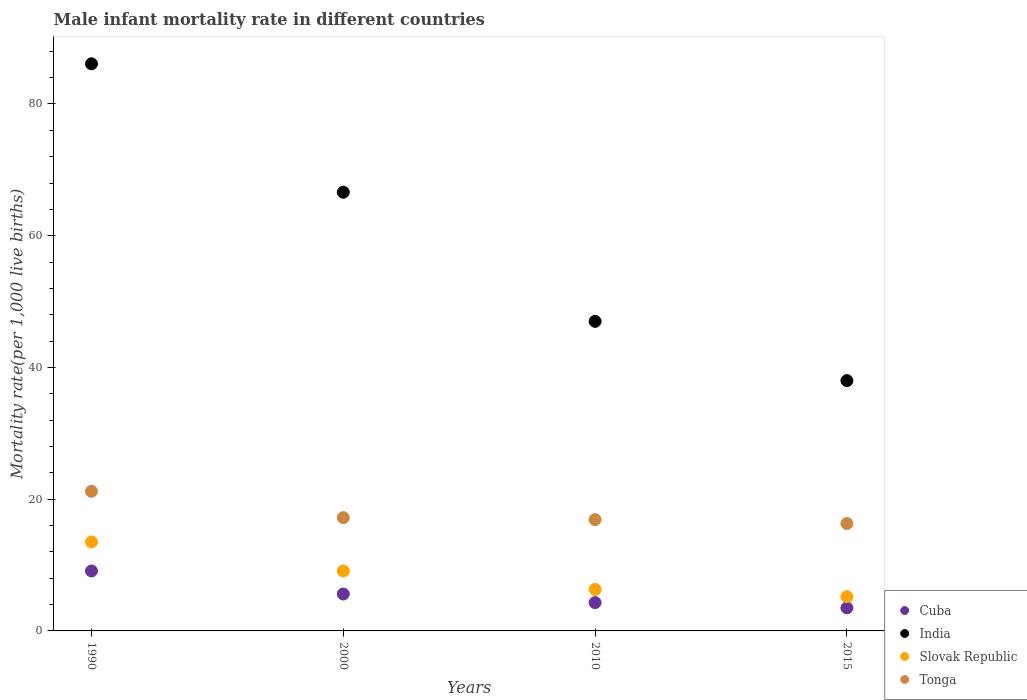What is the male infant mortality rate in India in 2000?
Your answer should be very brief. 66.6. In which year was the male infant mortality rate in Tonga minimum?
Offer a very short reply. 2015. What is the total male infant mortality rate in Tonga in the graph?
Provide a short and direct response. 71.6. What is the difference between the male infant mortality rate in Tonga in 2000 and that in 2015?
Ensure brevity in your answer.  0.9. What is the difference between the male infant mortality rate in Cuba in 1990 and the male infant mortality rate in Slovak Republic in 2000?
Offer a terse response. 0. In the year 2010, what is the difference between the male infant mortality rate in India and male infant mortality rate in Slovak Republic?
Your answer should be very brief. 40.7. What is the ratio of the male infant mortality rate in Cuba in 2010 to that in 2015?
Make the answer very short. 1.23. Is the male infant mortality rate in Cuba in 2010 less than that in 2015?
Keep it short and to the point. No. What is the difference between the highest and the second highest male infant mortality rate in Slovak Republic?
Give a very brief answer. 4.4. What is the difference between the highest and the lowest male infant mortality rate in Tonga?
Give a very brief answer. 4.9. In how many years, is the male infant mortality rate in Cuba greater than the average male infant mortality rate in Cuba taken over all years?
Make the answer very short. 1. Is the male infant mortality rate in Cuba strictly greater than the male infant mortality rate in India over the years?
Offer a terse response. No. How many years are there in the graph?
Give a very brief answer. 4. What is the difference between two consecutive major ticks on the Y-axis?
Your response must be concise. 20. Does the graph contain any zero values?
Provide a short and direct response. No. Does the graph contain grids?
Keep it short and to the point. No. How many legend labels are there?
Your answer should be compact. 4. What is the title of the graph?
Give a very brief answer. Male infant mortality rate in different countries. What is the label or title of the X-axis?
Your answer should be very brief. Years. What is the label or title of the Y-axis?
Provide a short and direct response. Mortality rate(per 1,0 live births). What is the Mortality rate(per 1,000 live births) in Cuba in 1990?
Offer a terse response. 9.1. What is the Mortality rate(per 1,000 live births) in India in 1990?
Ensure brevity in your answer.  86.1. What is the Mortality rate(per 1,000 live births) in Tonga in 1990?
Offer a terse response. 21.2. What is the Mortality rate(per 1,000 live births) in India in 2000?
Your answer should be very brief. 66.6. What is the Mortality rate(per 1,000 live births) of Tonga in 2000?
Provide a succinct answer. 17.2. What is the Mortality rate(per 1,000 live births) in India in 2010?
Provide a short and direct response. 47. What is the Mortality rate(per 1,000 live births) of India in 2015?
Offer a very short reply. 38. What is the Mortality rate(per 1,000 live births) in Slovak Republic in 2015?
Give a very brief answer. 5.2. What is the Mortality rate(per 1,000 live births) of Tonga in 2015?
Provide a short and direct response. 16.3. Across all years, what is the maximum Mortality rate(per 1,000 live births) in Cuba?
Give a very brief answer. 9.1. Across all years, what is the maximum Mortality rate(per 1,000 live births) in India?
Provide a short and direct response. 86.1. Across all years, what is the maximum Mortality rate(per 1,000 live births) in Tonga?
Give a very brief answer. 21.2. Across all years, what is the minimum Mortality rate(per 1,000 live births) in Cuba?
Keep it short and to the point. 3.5. Across all years, what is the minimum Mortality rate(per 1,000 live births) in Slovak Republic?
Your answer should be compact. 5.2. Across all years, what is the minimum Mortality rate(per 1,000 live births) of Tonga?
Make the answer very short. 16.3. What is the total Mortality rate(per 1,000 live births) in India in the graph?
Offer a terse response. 237.7. What is the total Mortality rate(per 1,000 live births) of Slovak Republic in the graph?
Keep it short and to the point. 34.1. What is the total Mortality rate(per 1,000 live births) of Tonga in the graph?
Ensure brevity in your answer.  71.6. What is the difference between the Mortality rate(per 1,000 live births) of Slovak Republic in 1990 and that in 2000?
Make the answer very short. 4.4. What is the difference between the Mortality rate(per 1,000 live births) in Tonga in 1990 and that in 2000?
Ensure brevity in your answer.  4. What is the difference between the Mortality rate(per 1,000 live births) in India in 1990 and that in 2010?
Keep it short and to the point. 39.1. What is the difference between the Mortality rate(per 1,000 live births) in India in 1990 and that in 2015?
Provide a short and direct response. 48.1. What is the difference between the Mortality rate(per 1,000 live births) of Slovak Republic in 1990 and that in 2015?
Make the answer very short. 8.3. What is the difference between the Mortality rate(per 1,000 live births) in Tonga in 1990 and that in 2015?
Offer a very short reply. 4.9. What is the difference between the Mortality rate(per 1,000 live births) of India in 2000 and that in 2010?
Give a very brief answer. 19.6. What is the difference between the Mortality rate(per 1,000 live births) in Slovak Republic in 2000 and that in 2010?
Provide a succinct answer. 2.8. What is the difference between the Mortality rate(per 1,000 live births) of Tonga in 2000 and that in 2010?
Keep it short and to the point. 0.3. What is the difference between the Mortality rate(per 1,000 live births) in Cuba in 2000 and that in 2015?
Provide a short and direct response. 2.1. What is the difference between the Mortality rate(per 1,000 live births) of India in 2000 and that in 2015?
Provide a succinct answer. 28.6. What is the difference between the Mortality rate(per 1,000 live births) in Tonga in 2000 and that in 2015?
Keep it short and to the point. 0.9. What is the difference between the Mortality rate(per 1,000 live births) in India in 2010 and that in 2015?
Make the answer very short. 9. What is the difference between the Mortality rate(per 1,000 live births) in Cuba in 1990 and the Mortality rate(per 1,000 live births) in India in 2000?
Your answer should be compact. -57.5. What is the difference between the Mortality rate(per 1,000 live births) of Cuba in 1990 and the Mortality rate(per 1,000 live births) of Slovak Republic in 2000?
Provide a succinct answer. 0. What is the difference between the Mortality rate(per 1,000 live births) of Cuba in 1990 and the Mortality rate(per 1,000 live births) of Tonga in 2000?
Your answer should be compact. -8.1. What is the difference between the Mortality rate(per 1,000 live births) in India in 1990 and the Mortality rate(per 1,000 live births) in Slovak Republic in 2000?
Provide a short and direct response. 77. What is the difference between the Mortality rate(per 1,000 live births) of India in 1990 and the Mortality rate(per 1,000 live births) of Tonga in 2000?
Offer a terse response. 68.9. What is the difference between the Mortality rate(per 1,000 live births) of Cuba in 1990 and the Mortality rate(per 1,000 live births) of India in 2010?
Your response must be concise. -37.9. What is the difference between the Mortality rate(per 1,000 live births) in Cuba in 1990 and the Mortality rate(per 1,000 live births) in Slovak Republic in 2010?
Offer a very short reply. 2.8. What is the difference between the Mortality rate(per 1,000 live births) in India in 1990 and the Mortality rate(per 1,000 live births) in Slovak Republic in 2010?
Your answer should be compact. 79.8. What is the difference between the Mortality rate(per 1,000 live births) of India in 1990 and the Mortality rate(per 1,000 live births) of Tonga in 2010?
Provide a succinct answer. 69.2. What is the difference between the Mortality rate(per 1,000 live births) of Cuba in 1990 and the Mortality rate(per 1,000 live births) of India in 2015?
Ensure brevity in your answer.  -28.9. What is the difference between the Mortality rate(per 1,000 live births) of Cuba in 1990 and the Mortality rate(per 1,000 live births) of Slovak Republic in 2015?
Your answer should be compact. 3.9. What is the difference between the Mortality rate(per 1,000 live births) in Cuba in 1990 and the Mortality rate(per 1,000 live births) in Tonga in 2015?
Offer a terse response. -7.2. What is the difference between the Mortality rate(per 1,000 live births) in India in 1990 and the Mortality rate(per 1,000 live births) in Slovak Republic in 2015?
Make the answer very short. 80.9. What is the difference between the Mortality rate(per 1,000 live births) of India in 1990 and the Mortality rate(per 1,000 live births) of Tonga in 2015?
Give a very brief answer. 69.8. What is the difference between the Mortality rate(per 1,000 live births) of Cuba in 2000 and the Mortality rate(per 1,000 live births) of India in 2010?
Offer a very short reply. -41.4. What is the difference between the Mortality rate(per 1,000 live births) in India in 2000 and the Mortality rate(per 1,000 live births) in Slovak Republic in 2010?
Your answer should be very brief. 60.3. What is the difference between the Mortality rate(per 1,000 live births) in India in 2000 and the Mortality rate(per 1,000 live births) in Tonga in 2010?
Give a very brief answer. 49.7. What is the difference between the Mortality rate(per 1,000 live births) of Slovak Republic in 2000 and the Mortality rate(per 1,000 live births) of Tonga in 2010?
Make the answer very short. -7.8. What is the difference between the Mortality rate(per 1,000 live births) in Cuba in 2000 and the Mortality rate(per 1,000 live births) in India in 2015?
Provide a short and direct response. -32.4. What is the difference between the Mortality rate(per 1,000 live births) of Cuba in 2000 and the Mortality rate(per 1,000 live births) of Tonga in 2015?
Your answer should be very brief. -10.7. What is the difference between the Mortality rate(per 1,000 live births) in India in 2000 and the Mortality rate(per 1,000 live births) in Slovak Republic in 2015?
Offer a very short reply. 61.4. What is the difference between the Mortality rate(per 1,000 live births) of India in 2000 and the Mortality rate(per 1,000 live births) of Tonga in 2015?
Your answer should be very brief. 50.3. What is the difference between the Mortality rate(per 1,000 live births) in Slovak Republic in 2000 and the Mortality rate(per 1,000 live births) in Tonga in 2015?
Ensure brevity in your answer.  -7.2. What is the difference between the Mortality rate(per 1,000 live births) of Cuba in 2010 and the Mortality rate(per 1,000 live births) of India in 2015?
Offer a terse response. -33.7. What is the difference between the Mortality rate(per 1,000 live births) in Cuba in 2010 and the Mortality rate(per 1,000 live births) in Tonga in 2015?
Provide a short and direct response. -12. What is the difference between the Mortality rate(per 1,000 live births) in India in 2010 and the Mortality rate(per 1,000 live births) in Slovak Republic in 2015?
Offer a very short reply. 41.8. What is the difference between the Mortality rate(per 1,000 live births) of India in 2010 and the Mortality rate(per 1,000 live births) of Tonga in 2015?
Keep it short and to the point. 30.7. What is the average Mortality rate(per 1,000 live births) in Cuba per year?
Provide a succinct answer. 5.62. What is the average Mortality rate(per 1,000 live births) in India per year?
Your answer should be very brief. 59.42. What is the average Mortality rate(per 1,000 live births) in Slovak Republic per year?
Offer a terse response. 8.53. In the year 1990, what is the difference between the Mortality rate(per 1,000 live births) in Cuba and Mortality rate(per 1,000 live births) in India?
Provide a succinct answer. -77. In the year 1990, what is the difference between the Mortality rate(per 1,000 live births) of Cuba and Mortality rate(per 1,000 live births) of Slovak Republic?
Make the answer very short. -4.4. In the year 1990, what is the difference between the Mortality rate(per 1,000 live births) of Cuba and Mortality rate(per 1,000 live births) of Tonga?
Provide a succinct answer. -12.1. In the year 1990, what is the difference between the Mortality rate(per 1,000 live births) of India and Mortality rate(per 1,000 live births) of Slovak Republic?
Offer a very short reply. 72.6. In the year 1990, what is the difference between the Mortality rate(per 1,000 live births) of India and Mortality rate(per 1,000 live births) of Tonga?
Provide a succinct answer. 64.9. In the year 1990, what is the difference between the Mortality rate(per 1,000 live births) of Slovak Republic and Mortality rate(per 1,000 live births) of Tonga?
Your answer should be very brief. -7.7. In the year 2000, what is the difference between the Mortality rate(per 1,000 live births) of Cuba and Mortality rate(per 1,000 live births) of India?
Your response must be concise. -61. In the year 2000, what is the difference between the Mortality rate(per 1,000 live births) in India and Mortality rate(per 1,000 live births) in Slovak Republic?
Make the answer very short. 57.5. In the year 2000, what is the difference between the Mortality rate(per 1,000 live births) of India and Mortality rate(per 1,000 live births) of Tonga?
Your answer should be compact. 49.4. In the year 2010, what is the difference between the Mortality rate(per 1,000 live births) of Cuba and Mortality rate(per 1,000 live births) of India?
Your answer should be very brief. -42.7. In the year 2010, what is the difference between the Mortality rate(per 1,000 live births) in India and Mortality rate(per 1,000 live births) in Slovak Republic?
Provide a short and direct response. 40.7. In the year 2010, what is the difference between the Mortality rate(per 1,000 live births) in India and Mortality rate(per 1,000 live births) in Tonga?
Make the answer very short. 30.1. In the year 2015, what is the difference between the Mortality rate(per 1,000 live births) in Cuba and Mortality rate(per 1,000 live births) in India?
Give a very brief answer. -34.5. In the year 2015, what is the difference between the Mortality rate(per 1,000 live births) of Cuba and Mortality rate(per 1,000 live births) of Slovak Republic?
Make the answer very short. -1.7. In the year 2015, what is the difference between the Mortality rate(per 1,000 live births) of India and Mortality rate(per 1,000 live births) of Slovak Republic?
Ensure brevity in your answer.  32.8. In the year 2015, what is the difference between the Mortality rate(per 1,000 live births) in India and Mortality rate(per 1,000 live births) in Tonga?
Ensure brevity in your answer.  21.7. What is the ratio of the Mortality rate(per 1,000 live births) in Cuba in 1990 to that in 2000?
Offer a terse response. 1.62. What is the ratio of the Mortality rate(per 1,000 live births) in India in 1990 to that in 2000?
Give a very brief answer. 1.29. What is the ratio of the Mortality rate(per 1,000 live births) of Slovak Republic in 1990 to that in 2000?
Ensure brevity in your answer.  1.48. What is the ratio of the Mortality rate(per 1,000 live births) in Tonga in 1990 to that in 2000?
Keep it short and to the point. 1.23. What is the ratio of the Mortality rate(per 1,000 live births) in Cuba in 1990 to that in 2010?
Your response must be concise. 2.12. What is the ratio of the Mortality rate(per 1,000 live births) of India in 1990 to that in 2010?
Your answer should be compact. 1.83. What is the ratio of the Mortality rate(per 1,000 live births) in Slovak Republic in 1990 to that in 2010?
Make the answer very short. 2.14. What is the ratio of the Mortality rate(per 1,000 live births) in Tonga in 1990 to that in 2010?
Ensure brevity in your answer.  1.25. What is the ratio of the Mortality rate(per 1,000 live births) of Cuba in 1990 to that in 2015?
Keep it short and to the point. 2.6. What is the ratio of the Mortality rate(per 1,000 live births) in India in 1990 to that in 2015?
Provide a succinct answer. 2.27. What is the ratio of the Mortality rate(per 1,000 live births) in Slovak Republic in 1990 to that in 2015?
Make the answer very short. 2.6. What is the ratio of the Mortality rate(per 1,000 live births) of Tonga in 1990 to that in 2015?
Offer a very short reply. 1.3. What is the ratio of the Mortality rate(per 1,000 live births) in Cuba in 2000 to that in 2010?
Provide a succinct answer. 1.3. What is the ratio of the Mortality rate(per 1,000 live births) in India in 2000 to that in 2010?
Offer a terse response. 1.42. What is the ratio of the Mortality rate(per 1,000 live births) in Slovak Republic in 2000 to that in 2010?
Your answer should be compact. 1.44. What is the ratio of the Mortality rate(per 1,000 live births) in Tonga in 2000 to that in 2010?
Your answer should be compact. 1.02. What is the ratio of the Mortality rate(per 1,000 live births) of Cuba in 2000 to that in 2015?
Your response must be concise. 1.6. What is the ratio of the Mortality rate(per 1,000 live births) in India in 2000 to that in 2015?
Your answer should be compact. 1.75. What is the ratio of the Mortality rate(per 1,000 live births) in Slovak Republic in 2000 to that in 2015?
Give a very brief answer. 1.75. What is the ratio of the Mortality rate(per 1,000 live births) of Tonga in 2000 to that in 2015?
Keep it short and to the point. 1.06. What is the ratio of the Mortality rate(per 1,000 live births) of Cuba in 2010 to that in 2015?
Give a very brief answer. 1.23. What is the ratio of the Mortality rate(per 1,000 live births) in India in 2010 to that in 2015?
Your response must be concise. 1.24. What is the ratio of the Mortality rate(per 1,000 live births) in Slovak Republic in 2010 to that in 2015?
Your answer should be compact. 1.21. What is the ratio of the Mortality rate(per 1,000 live births) in Tonga in 2010 to that in 2015?
Keep it short and to the point. 1.04. What is the difference between the highest and the second highest Mortality rate(per 1,000 live births) in Cuba?
Make the answer very short. 3.5. What is the difference between the highest and the second highest Mortality rate(per 1,000 live births) in Slovak Republic?
Make the answer very short. 4.4. What is the difference between the highest and the lowest Mortality rate(per 1,000 live births) of India?
Offer a very short reply. 48.1. What is the difference between the highest and the lowest Mortality rate(per 1,000 live births) of Slovak Republic?
Provide a succinct answer. 8.3. What is the difference between the highest and the lowest Mortality rate(per 1,000 live births) in Tonga?
Give a very brief answer. 4.9. 